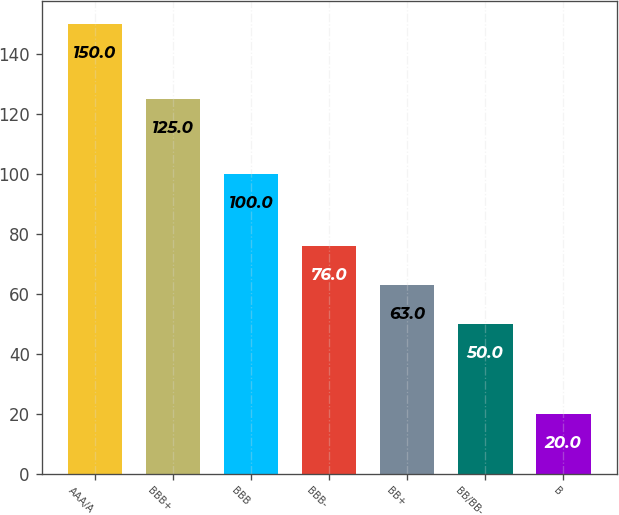Convert chart. <chart><loc_0><loc_0><loc_500><loc_500><bar_chart><fcel>AAA/A<fcel>BBB+<fcel>BBB<fcel>BBB-<fcel>BB+<fcel>BB/BB-<fcel>B<nl><fcel>150<fcel>125<fcel>100<fcel>76<fcel>63<fcel>50<fcel>20<nl></chart> 